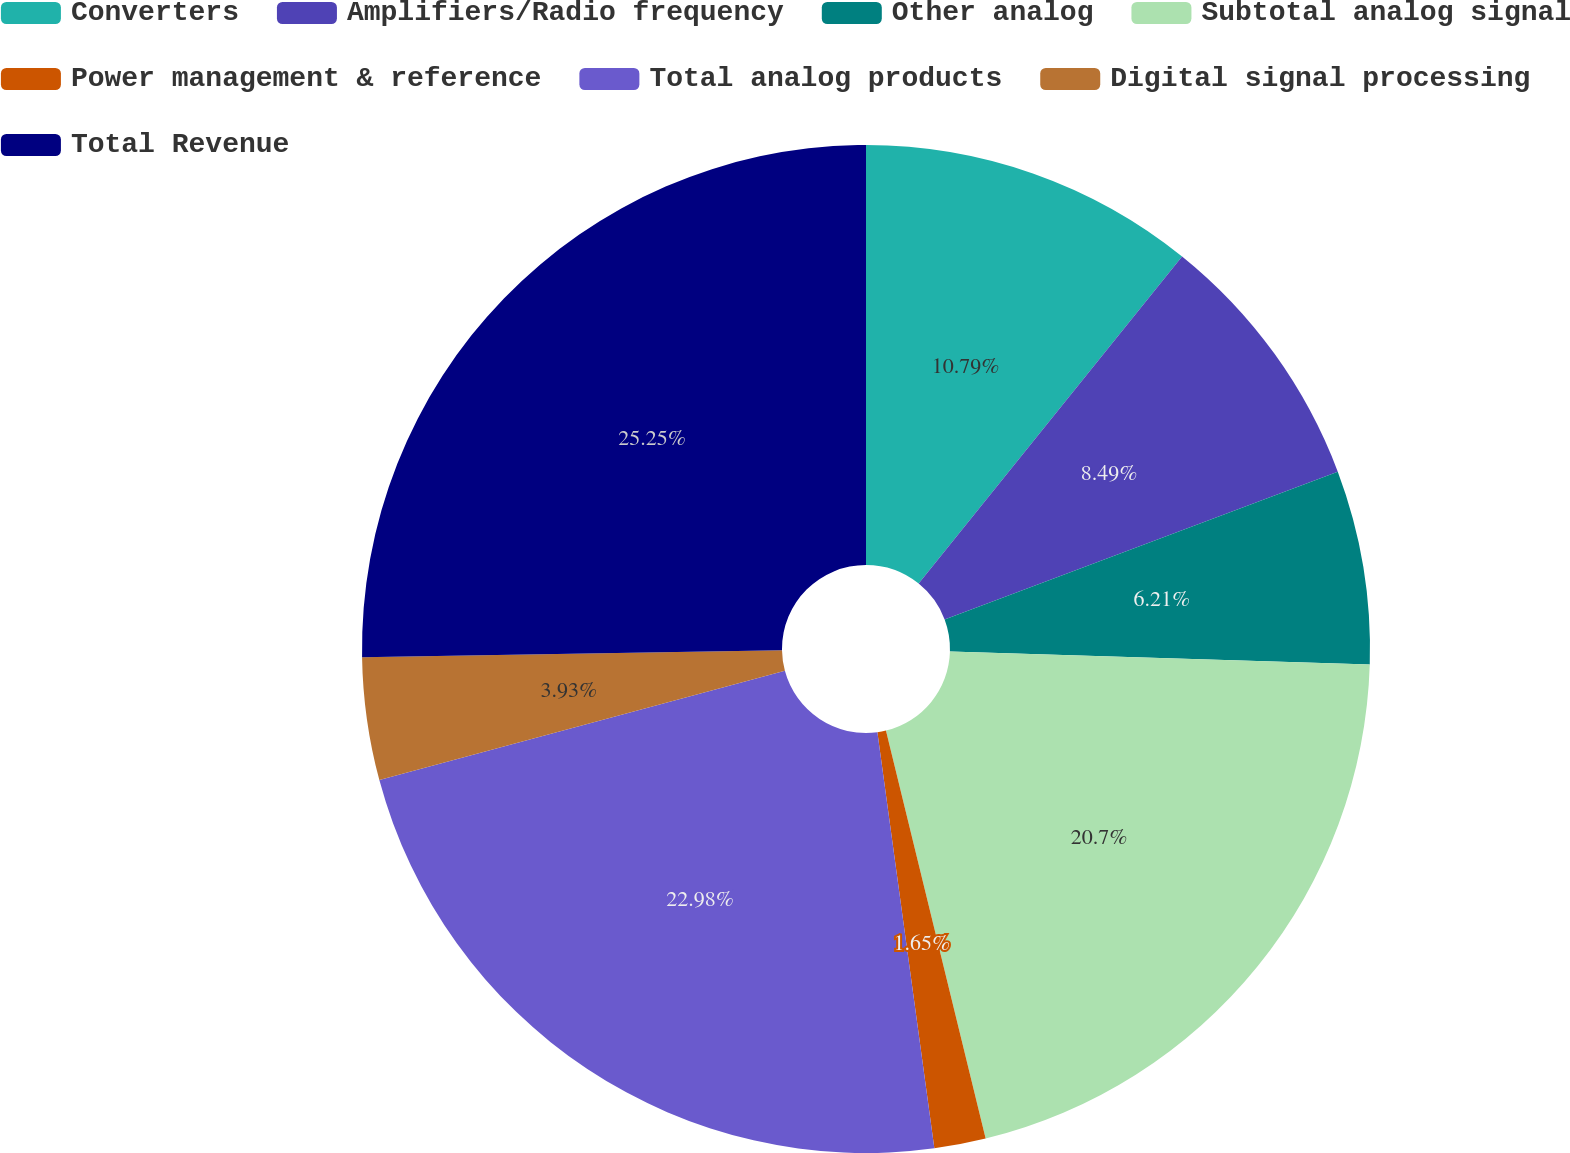Convert chart. <chart><loc_0><loc_0><loc_500><loc_500><pie_chart><fcel>Converters<fcel>Amplifiers/Radio frequency<fcel>Other analog<fcel>Subtotal analog signal<fcel>Power management & reference<fcel>Total analog products<fcel>Digital signal processing<fcel>Total Revenue<nl><fcel>10.79%<fcel>8.49%<fcel>6.21%<fcel>20.7%<fcel>1.65%<fcel>22.98%<fcel>3.93%<fcel>25.26%<nl></chart> 